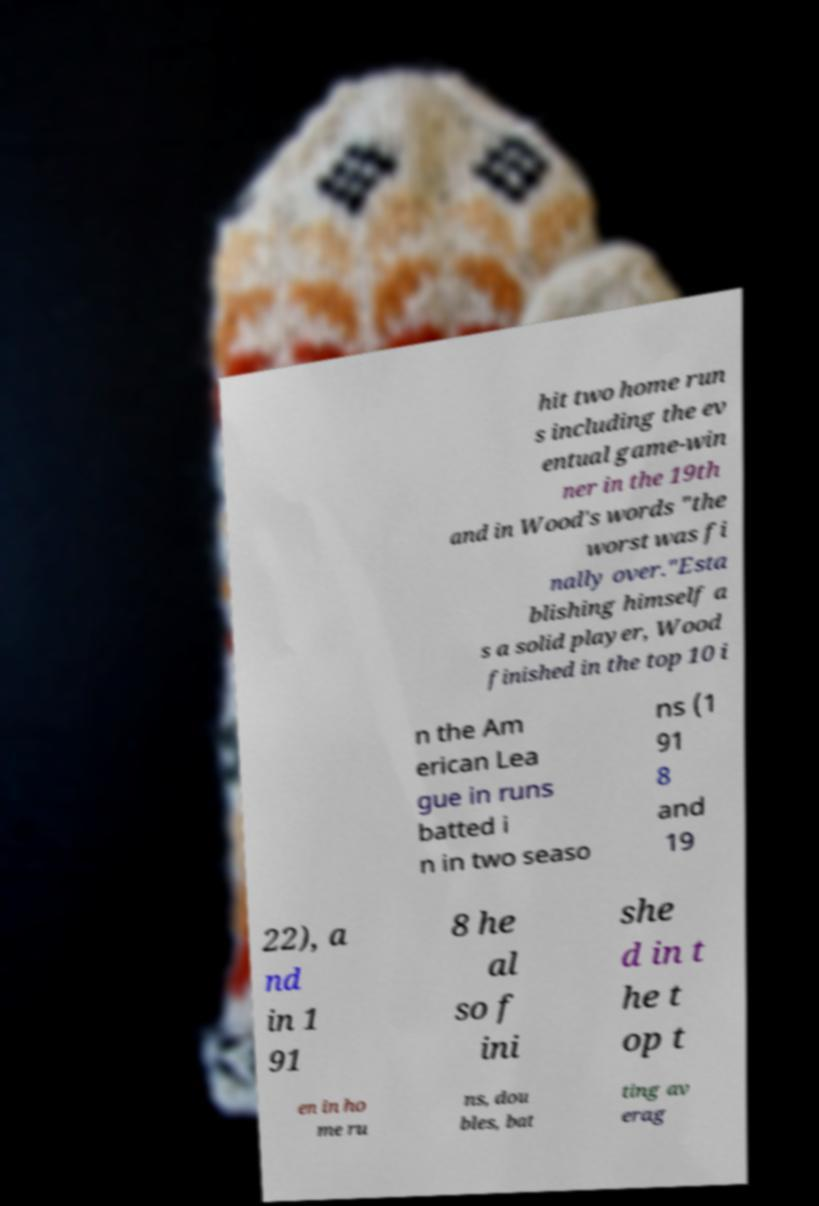There's text embedded in this image that I need extracted. Can you transcribe it verbatim? hit two home run s including the ev entual game-win ner in the 19th and in Wood's words "the worst was fi nally over."Esta blishing himself a s a solid player, Wood finished in the top 10 i n the Am erican Lea gue in runs batted i n in two seaso ns (1 91 8 and 19 22), a nd in 1 91 8 he al so f ini she d in t he t op t en in ho me ru ns, dou bles, bat ting av erag 